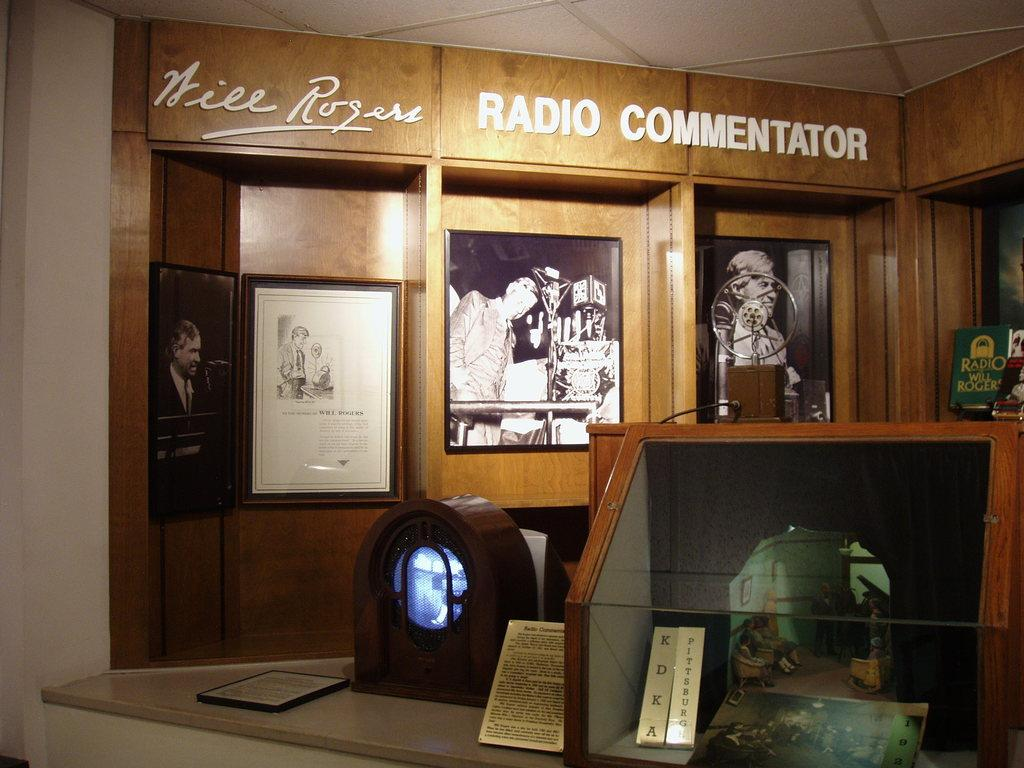<image>
Give a short and clear explanation of the subsequent image. Room that has the word "Radio Commentator" above some trophies. 